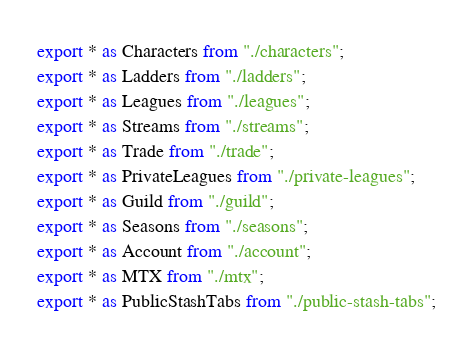Convert code to text. <code><loc_0><loc_0><loc_500><loc_500><_TypeScript_>export * as Characters from "./characters";
export * as Ladders from "./ladders";
export * as Leagues from "./leagues";
export * as Streams from "./streams";
export * as Trade from "./trade";
export * as PrivateLeagues from "./private-leagues";
export * as Guild from "./guild";
export * as Seasons from "./seasons";
export * as Account from "./account";
export * as MTX from "./mtx";
export * as PublicStashTabs from "./public-stash-tabs";
</code> 